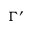<formula> <loc_0><loc_0><loc_500><loc_500>\Gamma ^ { \prime }</formula> 